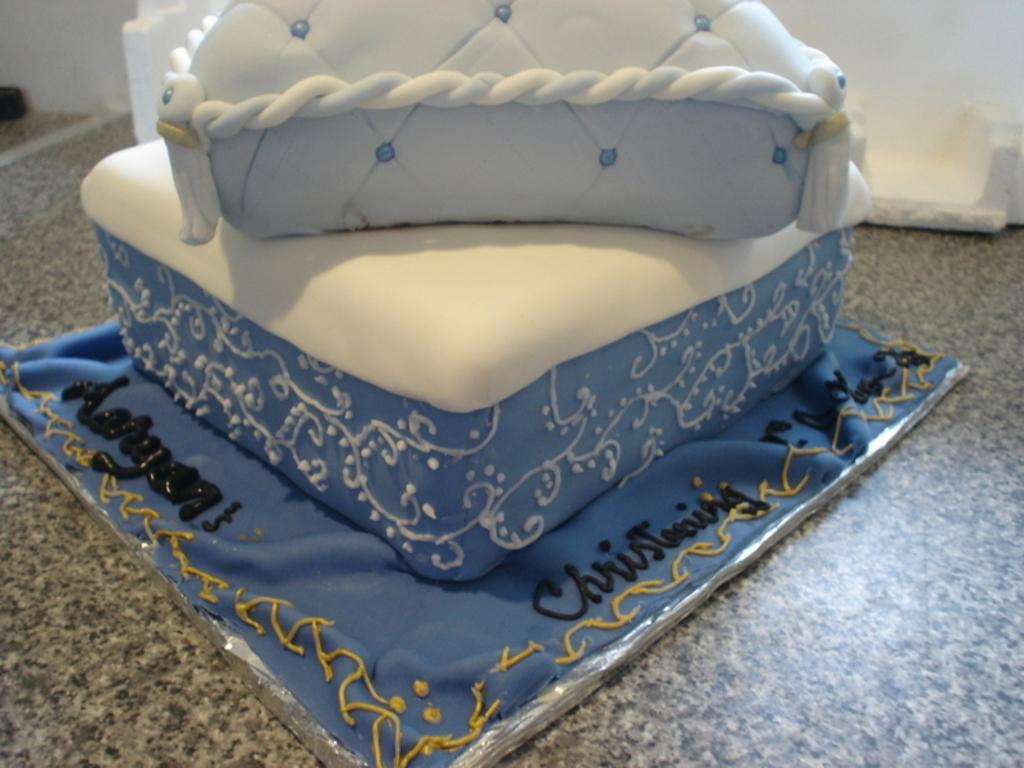What type of furniture or accessory is in the center of the image? There is a pillow, a quilt, and a stool in the center of the image. Can you describe the pillow in the image? The pillow is one of the items in the center of the image. What other item is in the center of the image besides the pillow? There is also a quilt and a stool in the center of the image. What type of steel is used to construct the table in the image? There is no table present in the image; it only features a pillow, a quilt, and a stool. What role does the governor play in the image? There is no governor present in the image, as it only features a pillow, a quilt, and a stool. 